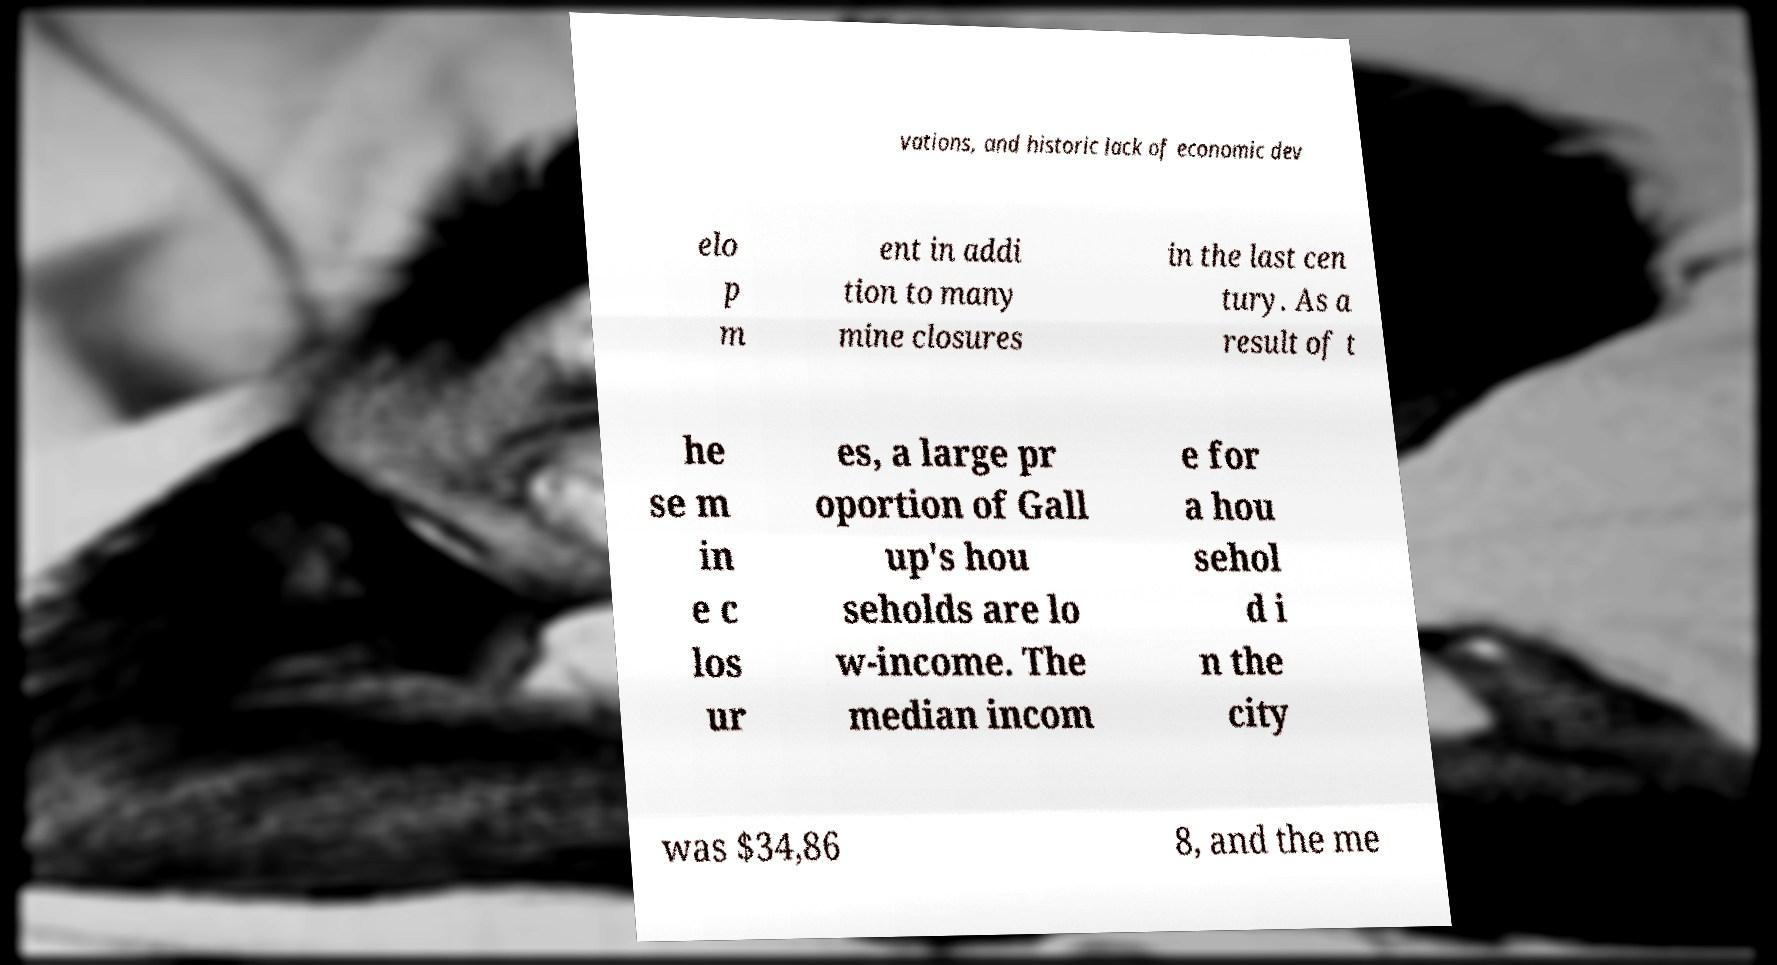Please identify and transcribe the text found in this image. vations, and historic lack of economic dev elo p m ent in addi tion to many mine closures in the last cen tury. As a result of t he se m in e c los ur es, a large pr oportion of Gall up's hou seholds are lo w-income. The median incom e for a hou sehol d i n the city was $34,86 8, and the me 